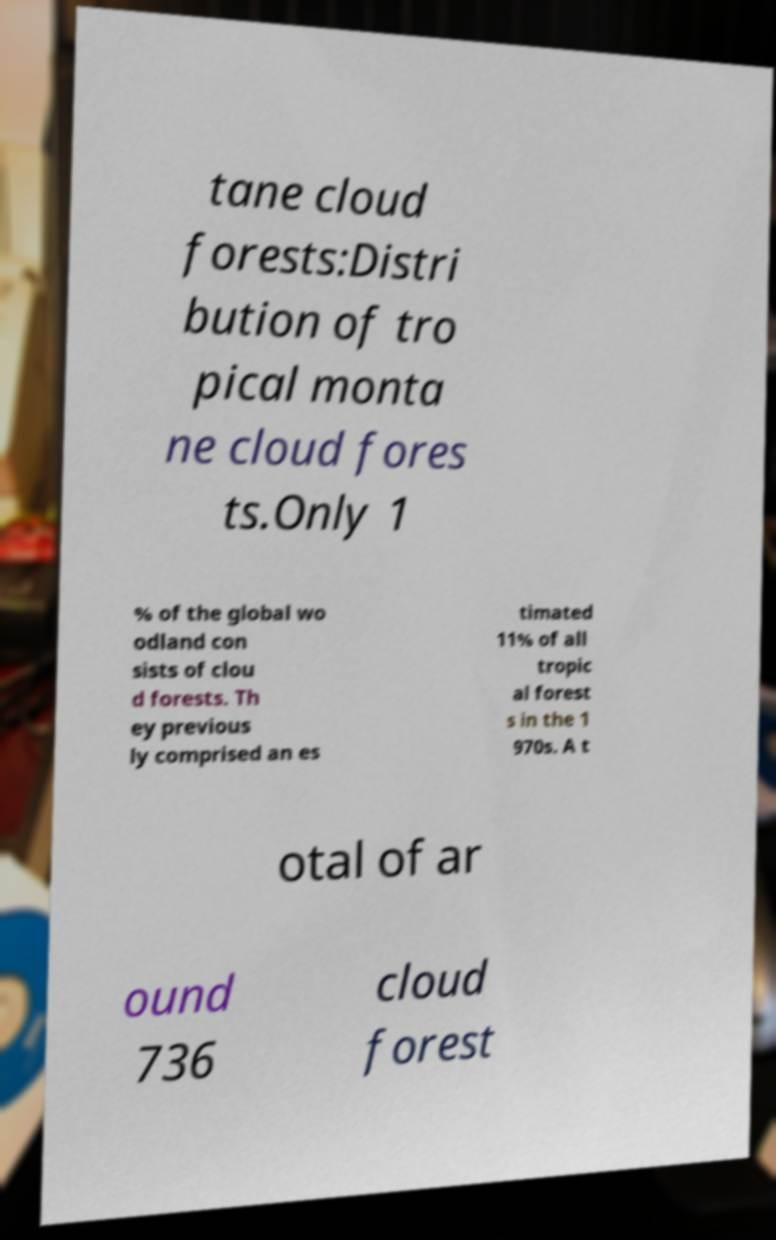Can you accurately transcribe the text from the provided image for me? tane cloud forests:Distri bution of tro pical monta ne cloud fores ts.Only 1 % of the global wo odland con sists of clou d forests. Th ey previous ly comprised an es timated 11% of all tropic al forest s in the 1 970s. A t otal of ar ound 736 cloud forest 